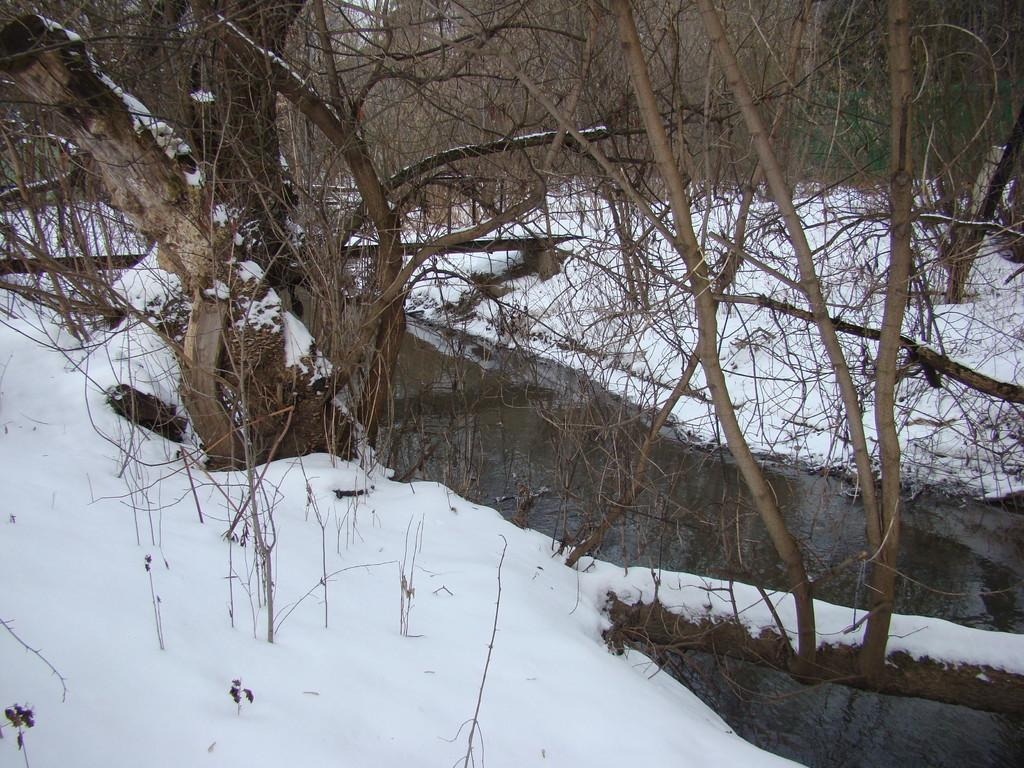What is the condition of the ground in the image? The ground is covered in snow. What natural element can be seen in the image? There is water visible in the image. What type of vegetation is present in the image? There are trees present in the image. What type of loaf can be seen in the image? There is no loaf present in the image. Are there any pests visible in the image? There is no mention of pests in the image, and they are not visible. 